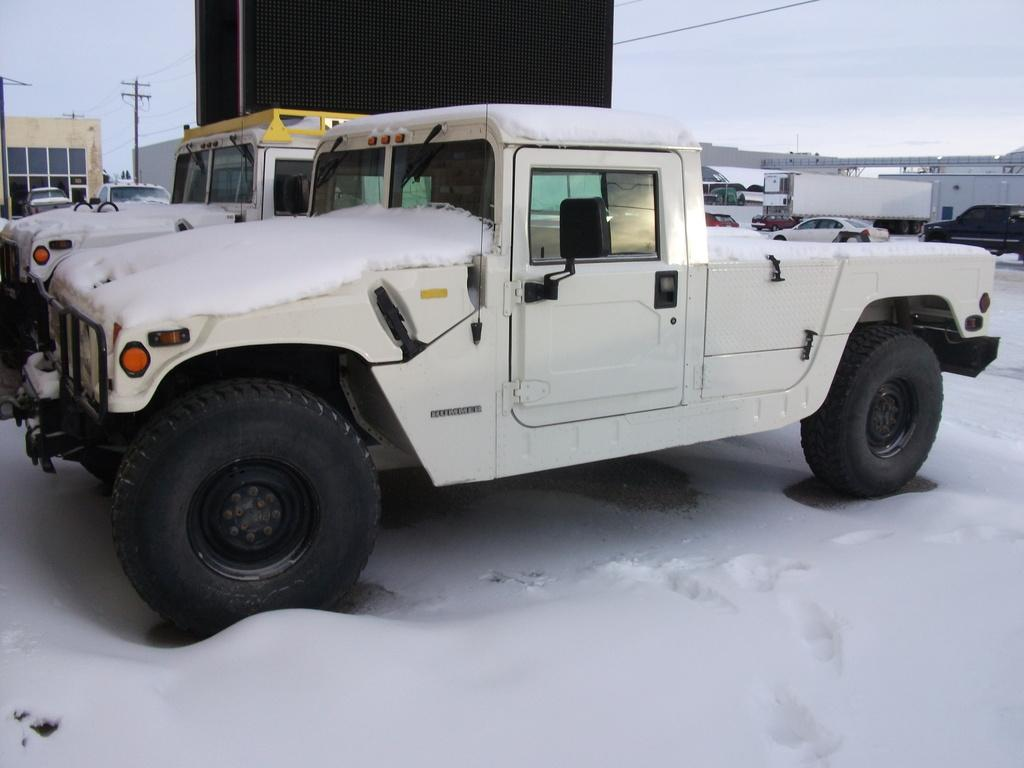What types of objects can be seen in the image? There are vehicles, sheds, poles with wires, a board, and a bridge in the image. Can you describe the environment in the image? There is snow at the bottom of the image. What might be used for communication in the image? The poles with wires in the image might be used for communication. What type of pencil can be seen in the image? There is no pencil present in the image. What kind of shop can be seen near the bridge in the image? There is no shop visible in the image; it only features a bridge, vehicles, sheds, poles with wires, and a board. 